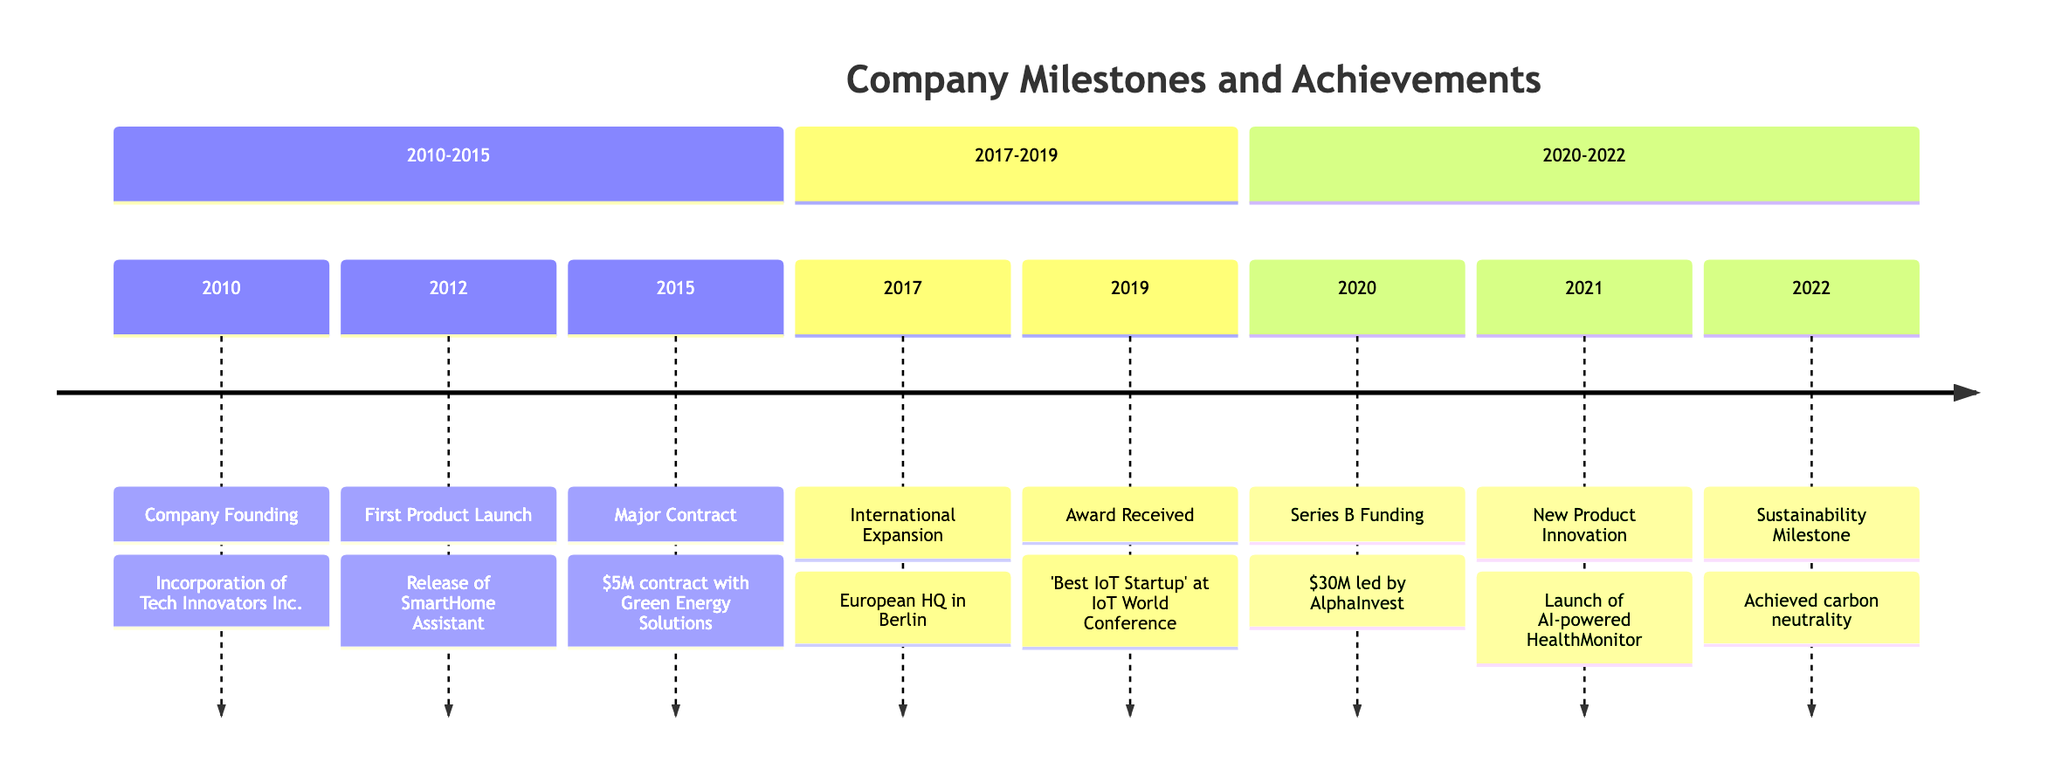What year was Tech Innovators Inc. founded? The diagram indicates that the founding event took place in 2010, which is stated as "Company Founding".
Answer: 2010 Which product was launched first by the company? According to the timeline, the first product launched was the SmartHome Assistant, which is labeled as "First Product Launch" in 2012.
Answer: SmartHome Assistant What major contract was secured in 2015? The diagram shows that the major contract secured in 2015 was with Green Energy Solutions for $5 million, noted in the timeline as "Major Contract".
Answer: $5 million contract with Green Energy Solutions How many product launches are highlighted in the timeline? The timeline highlights two product launches: the SmartHome Assistant in 2012 and the AI-powered HealthMonitor in 2021, which are both explicitly stated in their respective events.
Answer: 2 What significant event did the company achieve in 2022? The timeline shows that in 2022, the company achieved carbon neutrality, which is referred to as the "Sustainability Milestone".
Answer: Achieved carbon neutrality What year did the company expand internationally? The diagram indicates that the company opened its European headquarters in Berlin, Germany, marking its international expansion in 2017 as noted in the event description.
Answer: 2017 Which award did the company win in 2019? The timeline indicates that in 2019, the company was awarded 'Best IoT Startup' at the IoT World Conference, which is a significant highlight of that year.
Answer: Best IoT Startup How much was raised in Series B funding? The timeline shows that the company raised $30 million in Series B funding in 2020, as stated in the event description.
Answer: $30 million What was the focus of the new product launched in 2021? The diagram specifies that the new product launched in 2021 was the AI-powered HealthMonitor device, giving insight into the focus of that innovation.
Answer: AI-powered HealthMonitor 